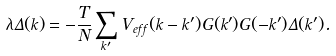<formula> <loc_0><loc_0><loc_500><loc_500>\lambda \Delta ( k ) = - \frac { T } { N } \sum _ { k ^ { \prime } } V _ { e f f } ( k - k ^ { \prime } ) G ( k ^ { \prime } ) G ( - k ^ { \prime } ) \Delta ( k ^ { \prime } ) .</formula> 